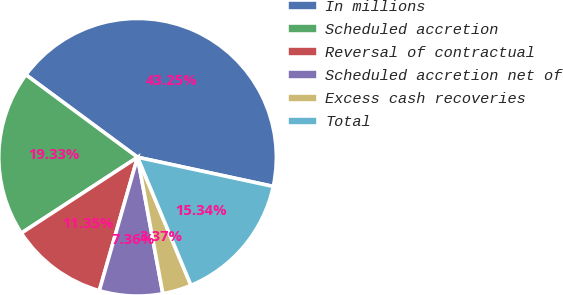<chart> <loc_0><loc_0><loc_500><loc_500><pie_chart><fcel>In millions<fcel>Scheduled accretion<fcel>Reversal of contractual<fcel>Scheduled accretion net of<fcel>Excess cash recoveries<fcel>Total<nl><fcel>43.25%<fcel>19.33%<fcel>11.35%<fcel>7.36%<fcel>3.37%<fcel>15.34%<nl></chart> 